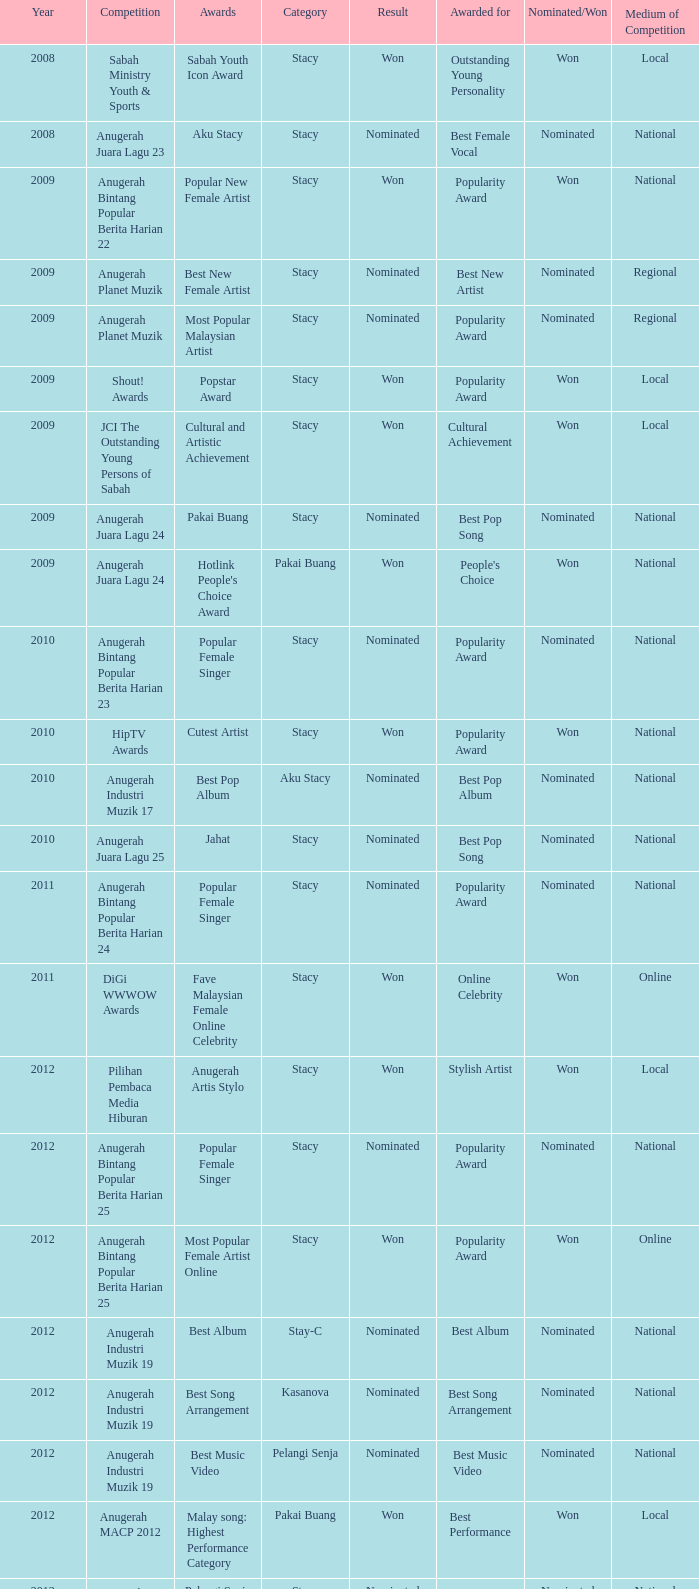What was the year that had Anugerah Bintang Popular Berita Harian 23 as competition? 1.0. 